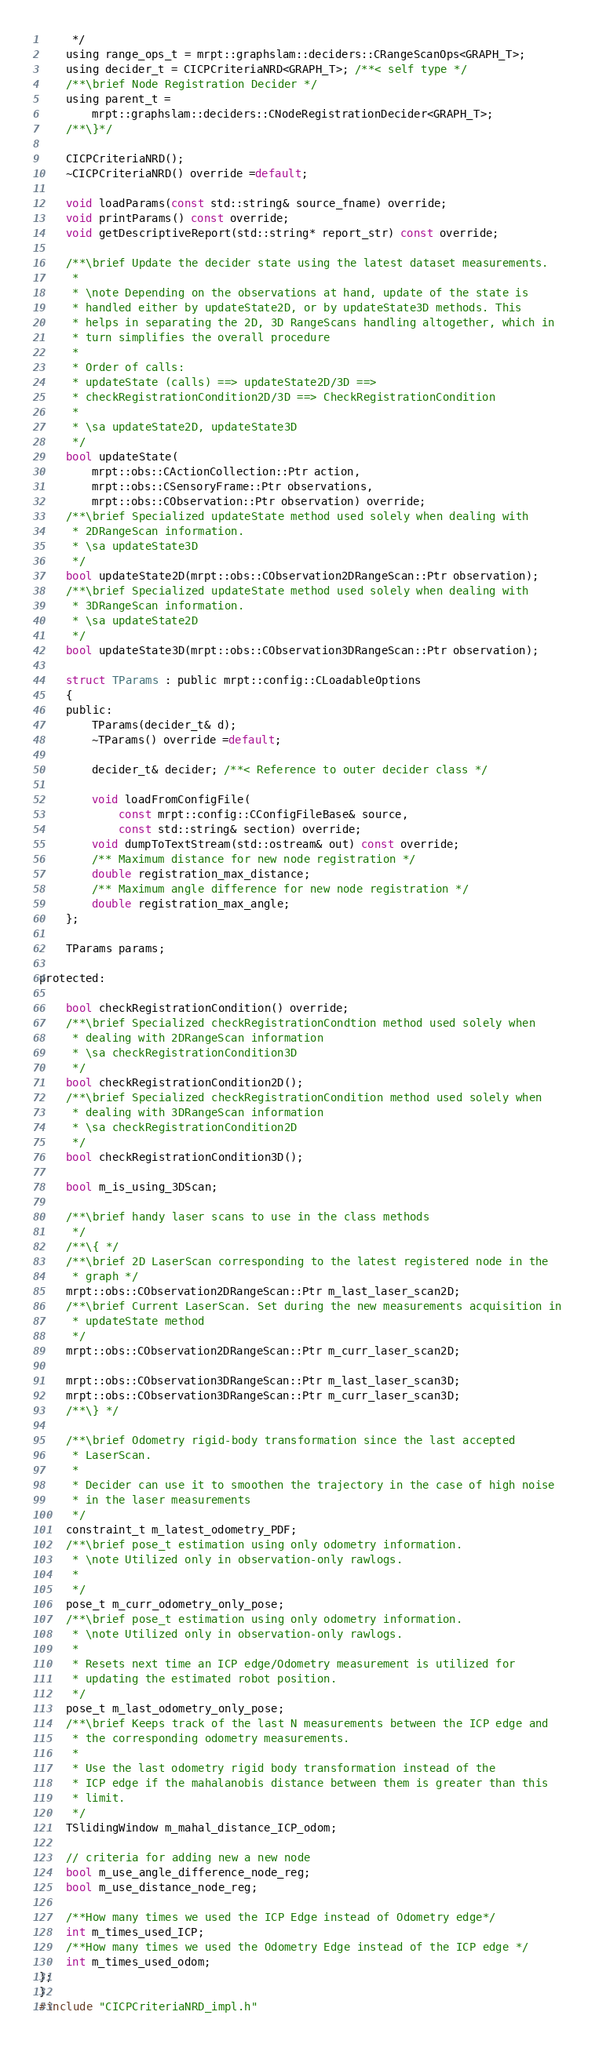<code> <loc_0><loc_0><loc_500><loc_500><_C_>	 */
	using range_ops_t = mrpt::graphslam::deciders::CRangeScanOps<GRAPH_T>;
	using decider_t = CICPCriteriaNRD<GRAPH_T>; /**< self type */
	/**\brief Node Registration Decider */
	using parent_t =
		mrpt::graphslam::deciders::CNodeRegistrationDecider<GRAPH_T>;
	/**\}*/

	CICPCriteriaNRD();
	~CICPCriteriaNRD() override =default;

	void loadParams(const std::string& source_fname) override;
	void printParams() const override;
	void getDescriptiveReport(std::string* report_str) const override;

	/**\brief Update the decider state using the latest dataset measurements.
	 *
	 * \note Depending on the observations at hand, update of the state is
	 * handled either by updateState2D, or by updateState3D methods. This
	 * helps in separating the 2D, 3D RangeScans handling altogether, which in
	 * turn simplifies the overall procedure
	 *
	 * Order of calls:
	 * updateState (calls) ==> updateState2D/3D ==>
	 * checkRegistrationCondition2D/3D ==> CheckRegistrationCondition
	 *
	 * \sa updateState2D, updateState3D
	 */
	bool updateState(
		mrpt::obs::CActionCollection::Ptr action,
		mrpt::obs::CSensoryFrame::Ptr observations,
		mrpt::obs::CObservation::Ptr observation) override;
	/**\brief Specialized updateState method used solely when dealing with
	 * 2DRangeScan information.
	 * \sa updateState3D
	 */
	bool updateState2D(mrpt::obs::CObservation2DRangeScan::Ptr observation);
	/**\brief Specialized updateState method used solely when dealing with
	 * 3DRangeScan information.
	 * \sa updateState2D
	 */
	bool updateState3D(mrpt::obs::CObservation3DRangeScan::Ptr observation);

	struct TParams : public mrpt::config::CLoadableOptions
	{
	public:
		TParams(decider_t& d);
		~TParams() override =default;

		decider_t& decider; /**< Reference to outer decider class */

		void loadFromConfigFile(
			const mrpt::config::CConfigFileBase& source,
			const std::string& section) override;
		void dumpToTextStream(std::ostream& out) const override;
		/** Maximum distance for new node registration */
		double registration_max_distance;
 		/** Maximum angle difference for new node registration */
		double registration_max_angle;
	};

	TParams params;

protected:

	bool checkRegistrationCondition() override;
	/**\brief Specialized checkRegistrationCondtion method used solely when
	 * dealing with 2DRangeScan information
	 * \sa checkRegistrationCondition3D
	 */
	bool checkRegistrationCondition2D();
	/**\brief Specialized checkRegistrationCondition method used solely when
	 * dealing with 3DRangeScan information
	 * \sa checkRegistrationCondition2D
	 */
	bool checkRegistrationCondition3D();

	bool m_is_using_3DScan;

	/**\brief handy laser scans to use in the class methods
	 */
	/**\{ */
	/**\brief 2D LaserScan corresponding to the latest registered node in the
	 * graph */
	mrpt::obs::CObservation2DRangeScan::Ptr m_last_laser_scan2D;
	/**\brief Current LaserScan. Set during the new measurements acquisition in
	 * updateState method
	 */
	mrpt::obs::CObservation2DRangeScan::Ptr m_curr_laser_scan2D;

	mrpt::obs::CObservation3DRangeScan::Ptr m_last_laser_scan3D;
	mrpt::obs::CObservation3DRangeScan::Ptr m_curr_laser_scan3D;
	/**\} */

	/**\brief Odometry rigid-body transformation since the last accepted
	 * LaserScan.
	 *
	 * Decider can use it to smoothen the trajectory in the case of high noise
	 * in the laser measurements
	 */
	constraint_t m_latest_odometry_PDF;
	/**\brief pose_t estimation using only odometry information.
	 * \note Utilized only in observation-only rawlogs.
	 *
	 */
	pose_t m_curr_odometry_only_pose;
	/**\brief pose_t estimation using only odometry information.
	 * \note Utilized only in observation-only rawlogs.
	 *
	 * Resets next time an ICP edge/Odometry measurement is utilized for
	 * updating the estimated robot position.
	 */
	pose_t m_last_odometry_only_pose;
	/**\brief Keeps track of the last N measurements between the ICP edge and
	 * the corresponding odometry measurements.
	 *
	 * Use the last odometry rigid body transformation instead of the
	 * ICP edge if the mahalanobis distance between them is greater than this
	 * limit.
	 */
	TSlidingWindow m_mahal_distance_ICP_odom;

	// criteria for adding new a new node
	bool m_use_angle_difference_node_reg;
	bool m_use_distance_node_reg;

	/**How many times we used the ICP Edge instead of Odometry edge*/
	int m_times_used_ICP;
	/**How many times we used the Odometry Edge instead of the ICP edge */
	int m_times_used_odom;
};
}
#include "CICPCriteriaNRD_impl.h"


</code> 